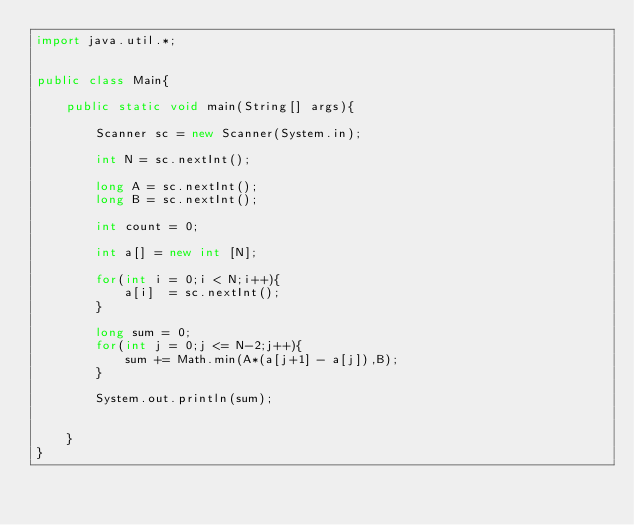Convert code to text. <code><loc_0><loc_0><loc_500><loc_500><_Java_>import java.util.*;


public class Main{    
    
    public static void main(String[] args){            
       
        Scanner sc = new Scanner(System.in);        
                      
        int N = sc.nextInt();

        long A = sc.nextInt();
        long B = sc.nextInt();
        
        int count = 0;
        
        int a[] = new int [N];
        
        for(int i = 0;i < N;i++){
            a[i]  = sc.nextInt();           
        }
        
        long sum = 0;
        for(int j = 0;j <= N-2;j++){
            sum += Math.min(A*(a[j+1] - a[j]),B);
        }
        
        System.out.println(sum);
                
                        
    }                                       
}</code> 